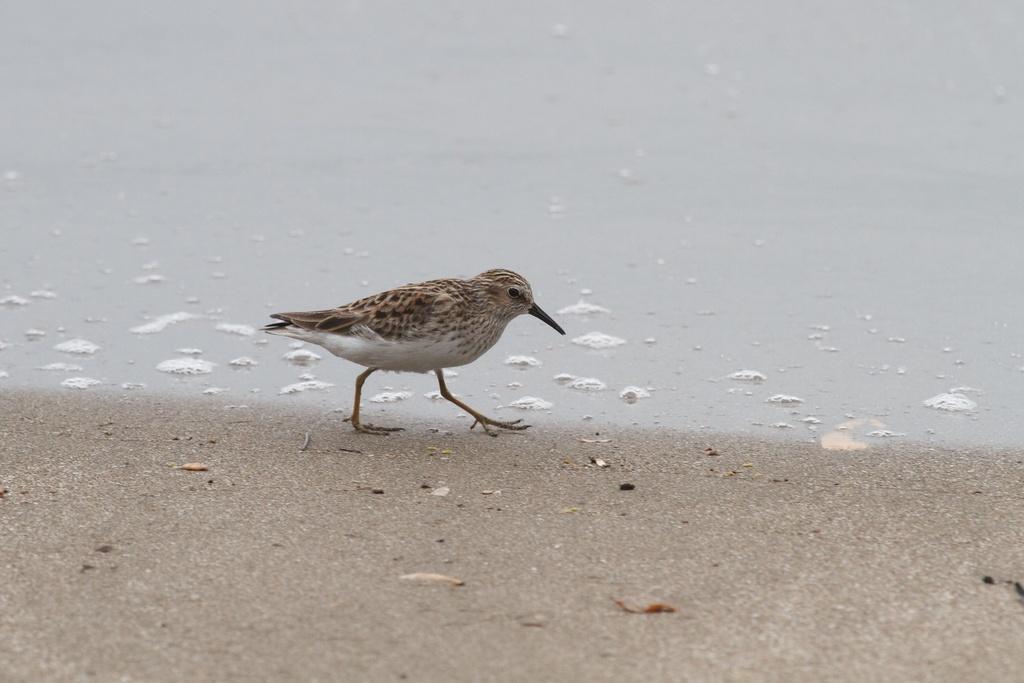Can you describe this image briefly? A bird is walking. There is water at the back. 